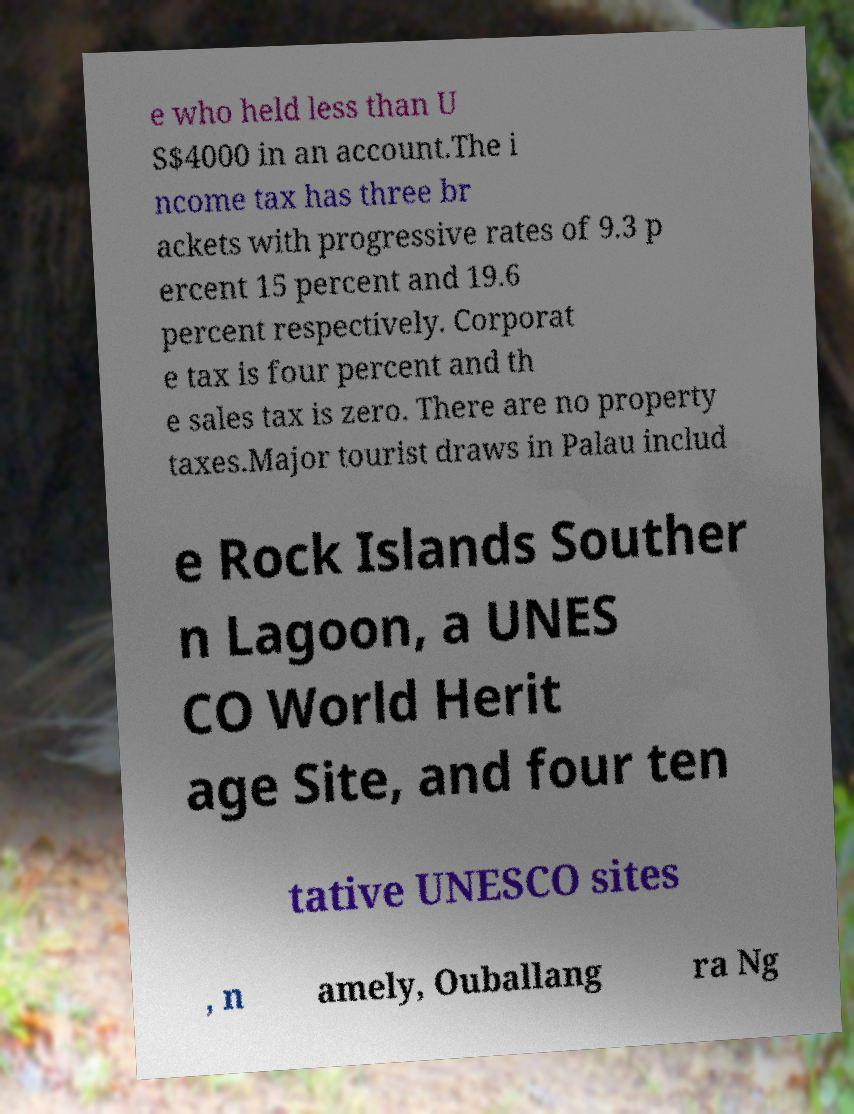Could you extract and type out the text from this image? e who held less than U S$4000 in an account.The i ncome tax has three br ackets with progressive rates of 9.3 p ercent 15 percent and 19.6 percent respectively. Corporat e tax is four percent and th e sales tax is zero. There are no property taxes.Major tourist draws in Palau includ e Rock Islands Souther n Lagoon, a UNES CO World Herit age Site, and four ten tative UNESCO sites , n amely, Ouballang ra Ng 